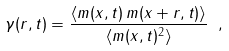<formula> <loc_0><loc_0><loc_500><loc_500>\gamma ( r , t ) = \frac { \langle m ( { x } , t ) \, m ( { x } + { r } , t ) \rangle } { \langle m ( { x } , t ) ^ { 2 } \rangle } \ ,</formula> 